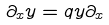<formula> <loc_0><loc_0><loc_500><loc_500>\partial _ { x } y = q y \partial _ { x }</formula> 